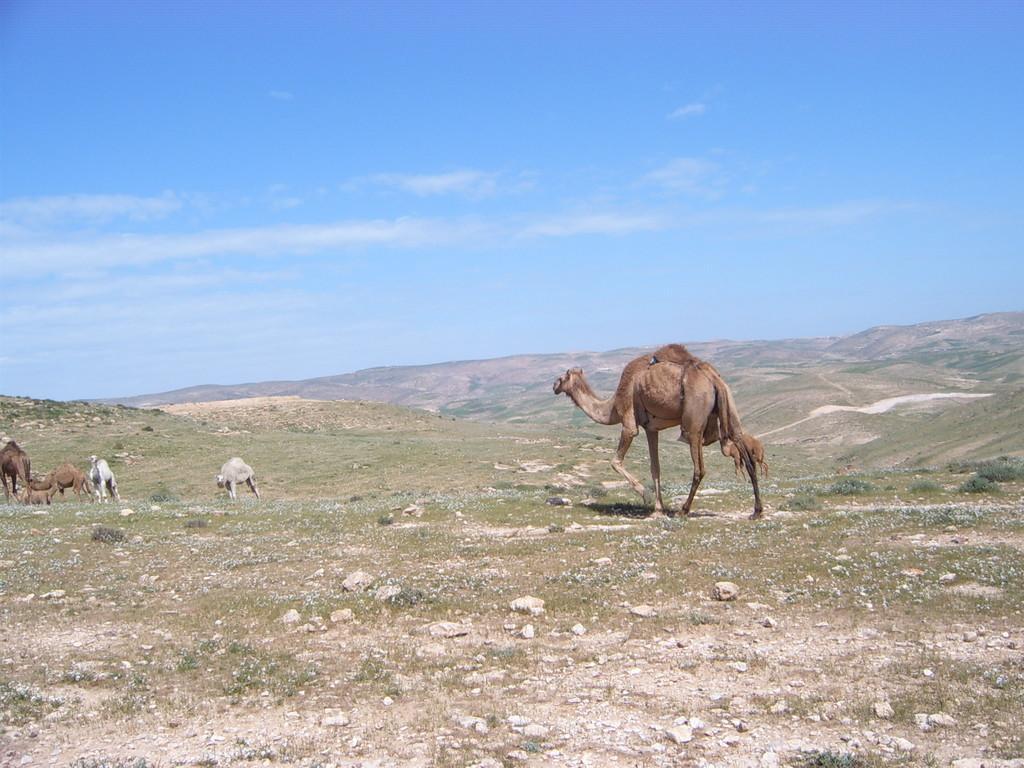In one or two sentences, can you explain what this image depicts? In this image there is one camel at right side of this image and there are three camels at left side of this image and one camel at middle left side of this image and there is a dessert area as we can see in middle of this image and there is a blue sky at top of this image. 